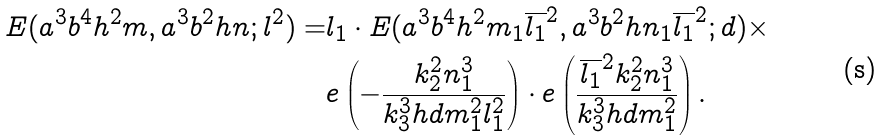Convert formula to latex. <formula><loc_0><loc_0><loc_500><loc_500>E ( a ^ { 3 } b ^ { 4 } h ^ { 2 } m , a ^ { 3 } b ^ { 2 } h n ; l ^ { 2 } ) = & l _ { 1 } \cdot E ( a ^ { 3 } b ^ { 4 } h ^ { 2 } m _ { 1 } \overline { l _ { 1 } } ^ { 2 } , a ^ { 3 } b ^ { 2 } h n _ { 1 } \overline { l _ { 1 } } ^ { 2 } ; d ) \times \\ & e \left ( - \frac { k _ { 2 } ^ { 2 } n _ { 1 } ^ { 3 } } { k _ { 3 } ^ { 3 } h d m _ { 1 } ^ { 2 } l _ { 1 } ^ { 2 } } \right ) \cdot e \left ( \frac { \overline { l _ { 1 } } ^ { 2 } k _ { 2 } ^ { 2 } n _ { 1 } ^ { 3 } } { k _ { 3 } ^ { 3 } h d m _ { 1 } ^ { 2 } } \right ) .</formula> 